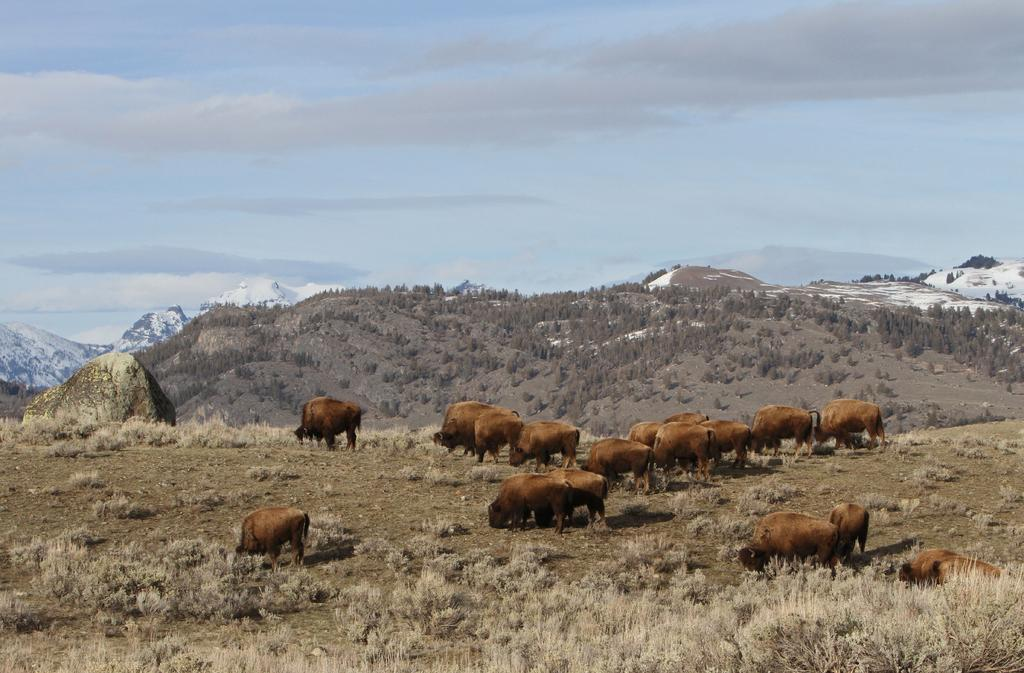What is located in the foreground of the image? There are animals in the foreground of the image. What type of terrain are the animals on? The animals are on dry grassland. What can be seen in the background of the image? There are trees and mountains in the background of the image. What part of the natural environment is visible in the image? The sky is visible in the background of the image. How many books can be seen in the image? There are no books present in the image. What color is the balloon that the animals are holding in the image? There is no balloon present in the image. 